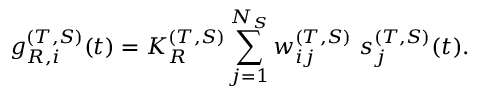Convert formula to latex. <formula><loc_0><loc_0><loc_500><loc_500>g _ { R , i } ^ { ( T , S ) } ( t ) = K _ { R } ^ { ( T , S ) } \sum _ { j = 1 } ^ { N _ { S } } w _ { i j } ^ { ( T , S ) } s _ { j } ^ { ( T , S ) } ( t ) .</formula> 